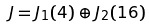Convert formula to latex. <formula><loc_0><loc_0><loc_500><loc_500>J = J _ { 1 } ( 4 ) \oplus J _ { 2 } ( 1 6 )</formula> 